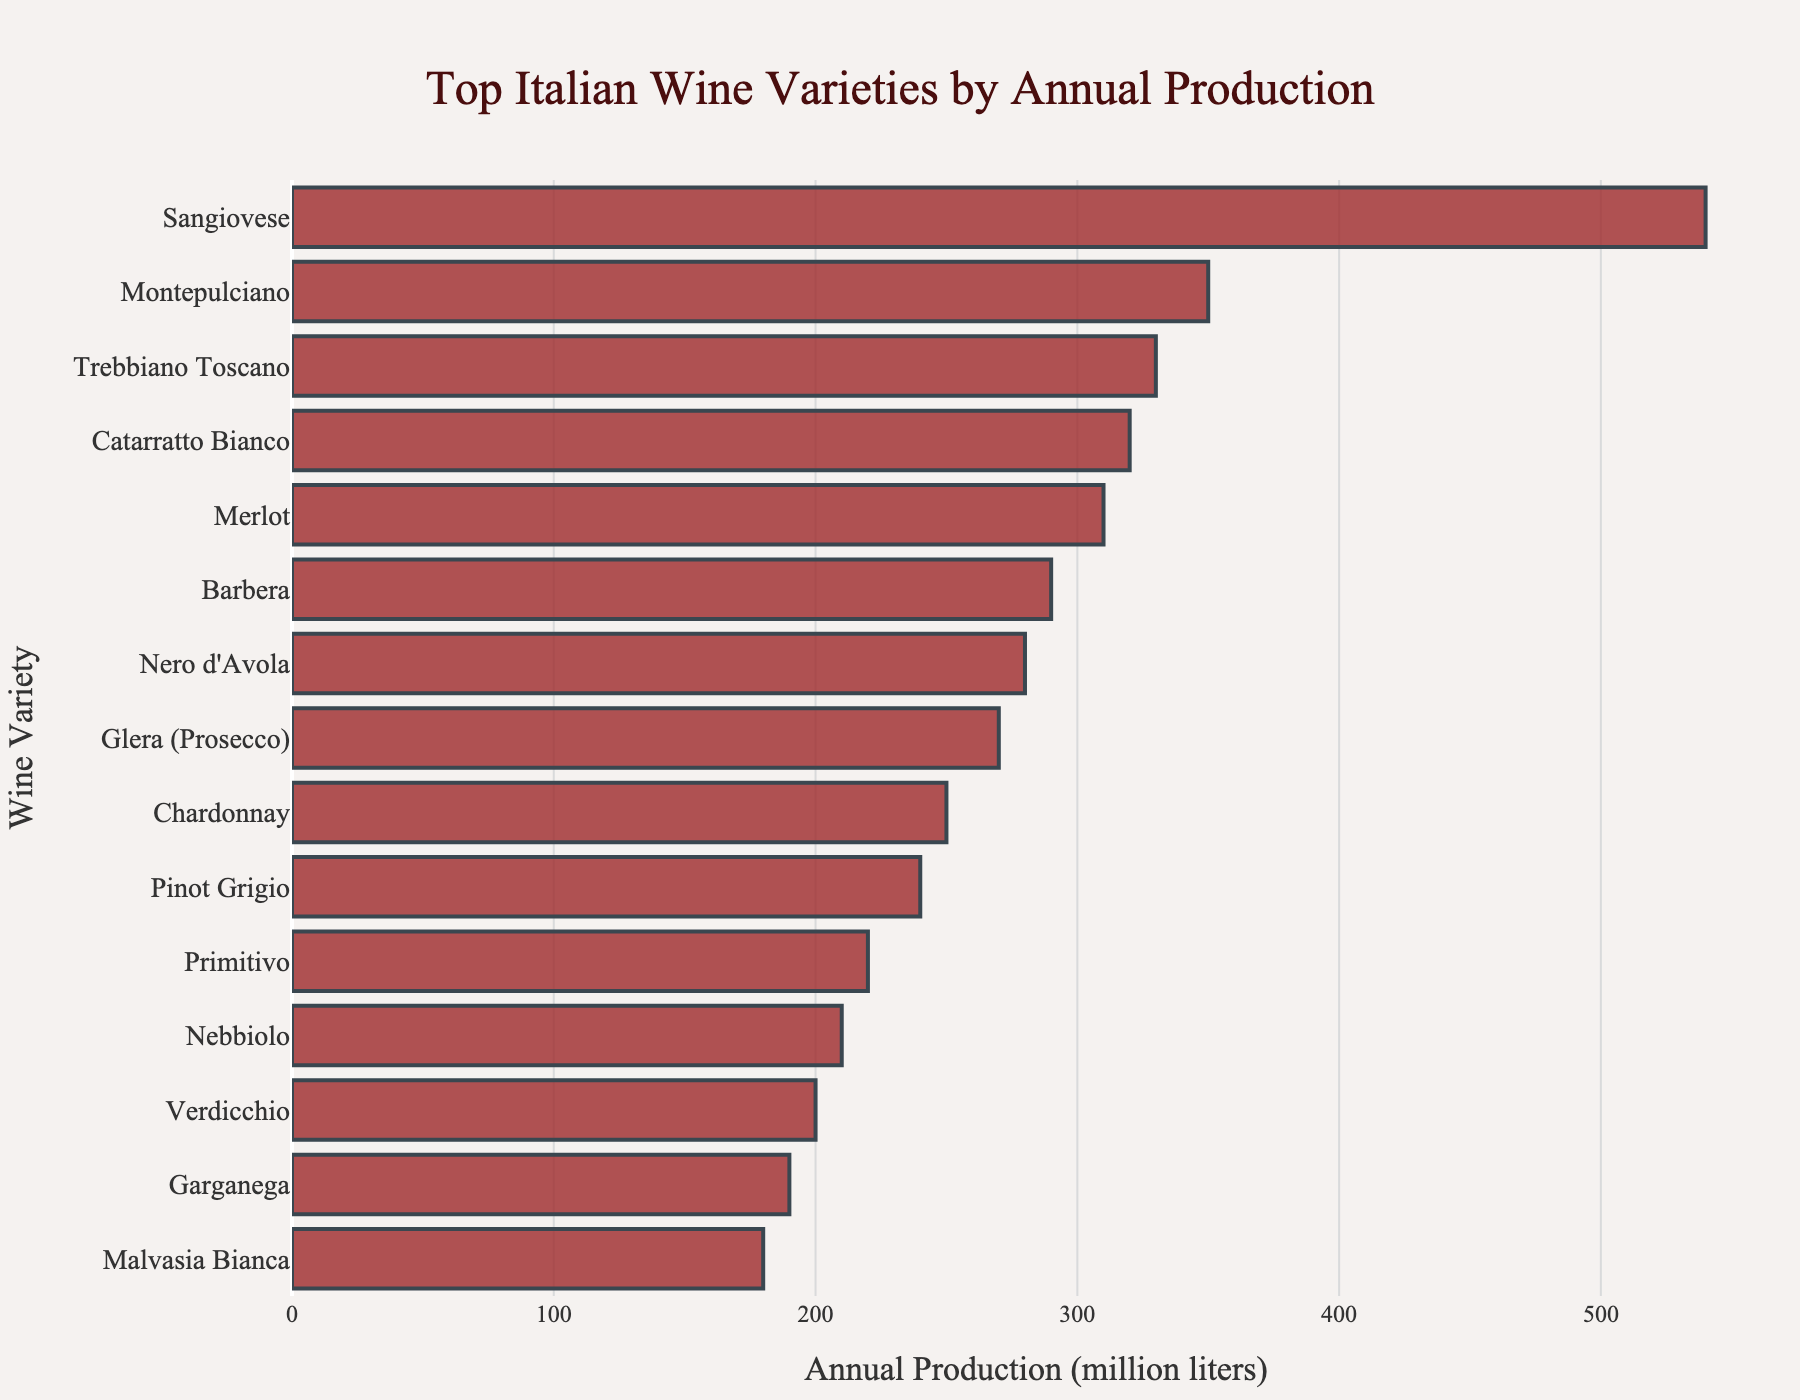Which wine variety has the highest annual production? The bar chart shows the wine varieties along the y-axis and their annual production in million liters along the x-axis. By inspecting the longest bar, we see that "Sangiovese" has the highest annual production.
Answer: Sangiovese Which wine variety has the lowest annual production? By inspecting the shortest bar in the bar chart from the visual information, "Malvasia Bianca" is identified as having the lowest annual production.
Answer: Malvasia Bianca What is the difference in annual production between Sangiovese and Montepulciano? Sangiovese has an annual production of 540 million liters, and Montepulciano's production is 350 million liters. The difference is calculated as 540 - 350.
Answer: 190 Arrange the top 3 wine varieties in descending order of annual production. The top 3 wine varieties by annual production are Sangiovese (540 million liters), Montepulciano (350 million liters), and Trebbiano Toscano (330 million liters).
Answer: Sangiovese, Montepulciano, Trebbiano Toscano Which wine variety has lower production, Chardonnay or Pinot Grigio? From the visual inspection of the bar lengths, Pinot Grigio has a higher production (240 million liters) compared to Chardonnay (250 million liters).
Answer: Chardonnay What is the total annual production of Glera (Prosecco) and Barbera combined? The annual production of Glera (Prosecco) is 270 million liters, and Barbera is 290 million liters. Adding them together gives us 270 + 290.
Answer: 560 How much more does Chardonnay produce than Verdicchio? Chardonnay has an annual production of 250 million liters, while Verdicchio produces 200 million liters. The difference is calculated as 250 - 200.
Answer: 50 Which wine variety has an annual production closest to 300 million liters? On inspecting the bar lengths, Merlot and Catarratto Bianco are close to 300 million liters, but Merlot has 310 million liters which is closer to 300 million liters compared to Catarratto Bianco's 320 million liters.
Answer: Merlot Compare the annual production of Nero d'Avola and Primitivo, which one has higher production? By inspecting the bar chart's visual information, Nero d'Avola has an annual production of 280 million liters, while Primitivo has 220 million liters, making Nero d'Avola higher in production.
Answer: Nero d'Avola What is the average annual production of the top 5 wine varieties? The top 5 wine varieties and their production are Sangiovese (540), Montepulciano (350), Trebbiano Toscano (330), Catarratto Bianco (320), and Merlot (310). The average is calculated as (540 + 350 + 330 + 320 + 310) / 5.
Answer: 370 